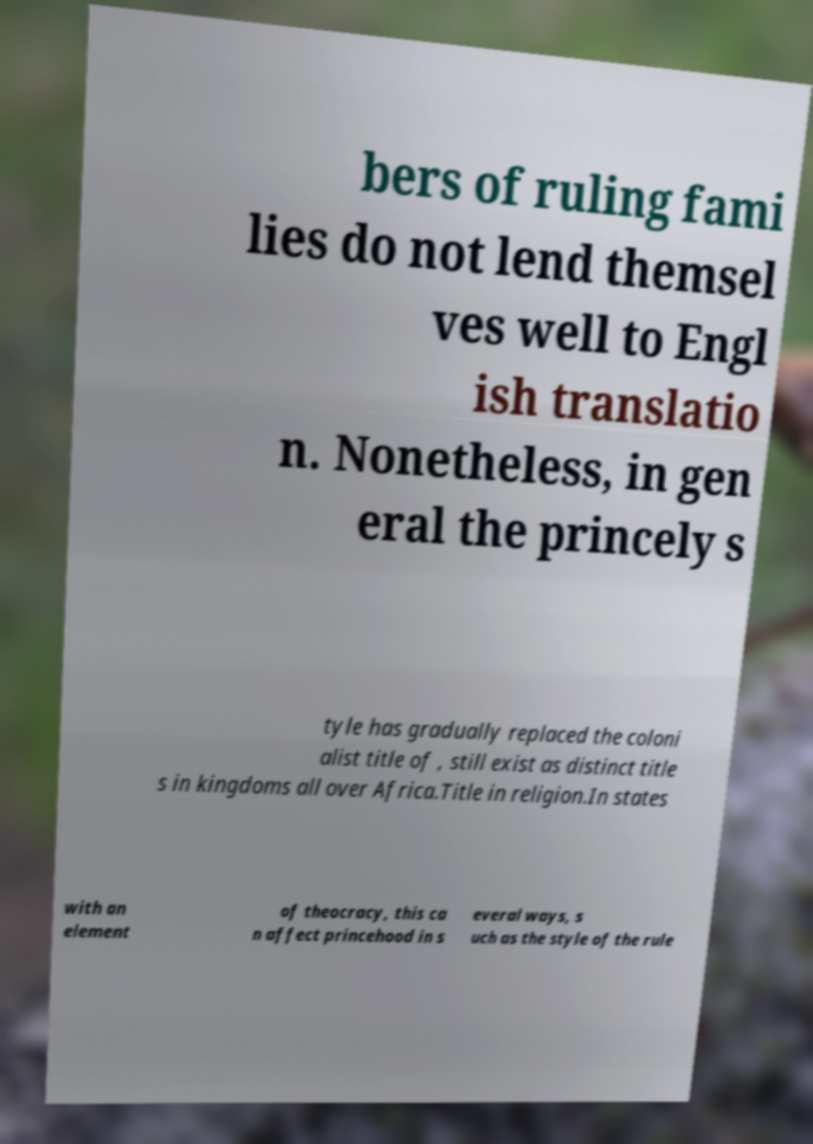I need the written content from this picture converted into text. Can you do that? bers of ruling fami lies do not lend themsel ves well to Engl ish translatio n. Nonetheless, in gen eral the princely s tyle has gradually replaced the coloni alist title of , still exist as distinct title s in kingdoms all over Africa.Title in religion.In states with an element of theocracy, this ca n affect princehood in s everal ways, s uch as the style of the rule 